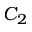<formula> <loc_0><loc_0><loc_500><loc_500>C _ { 2 }</formula> 